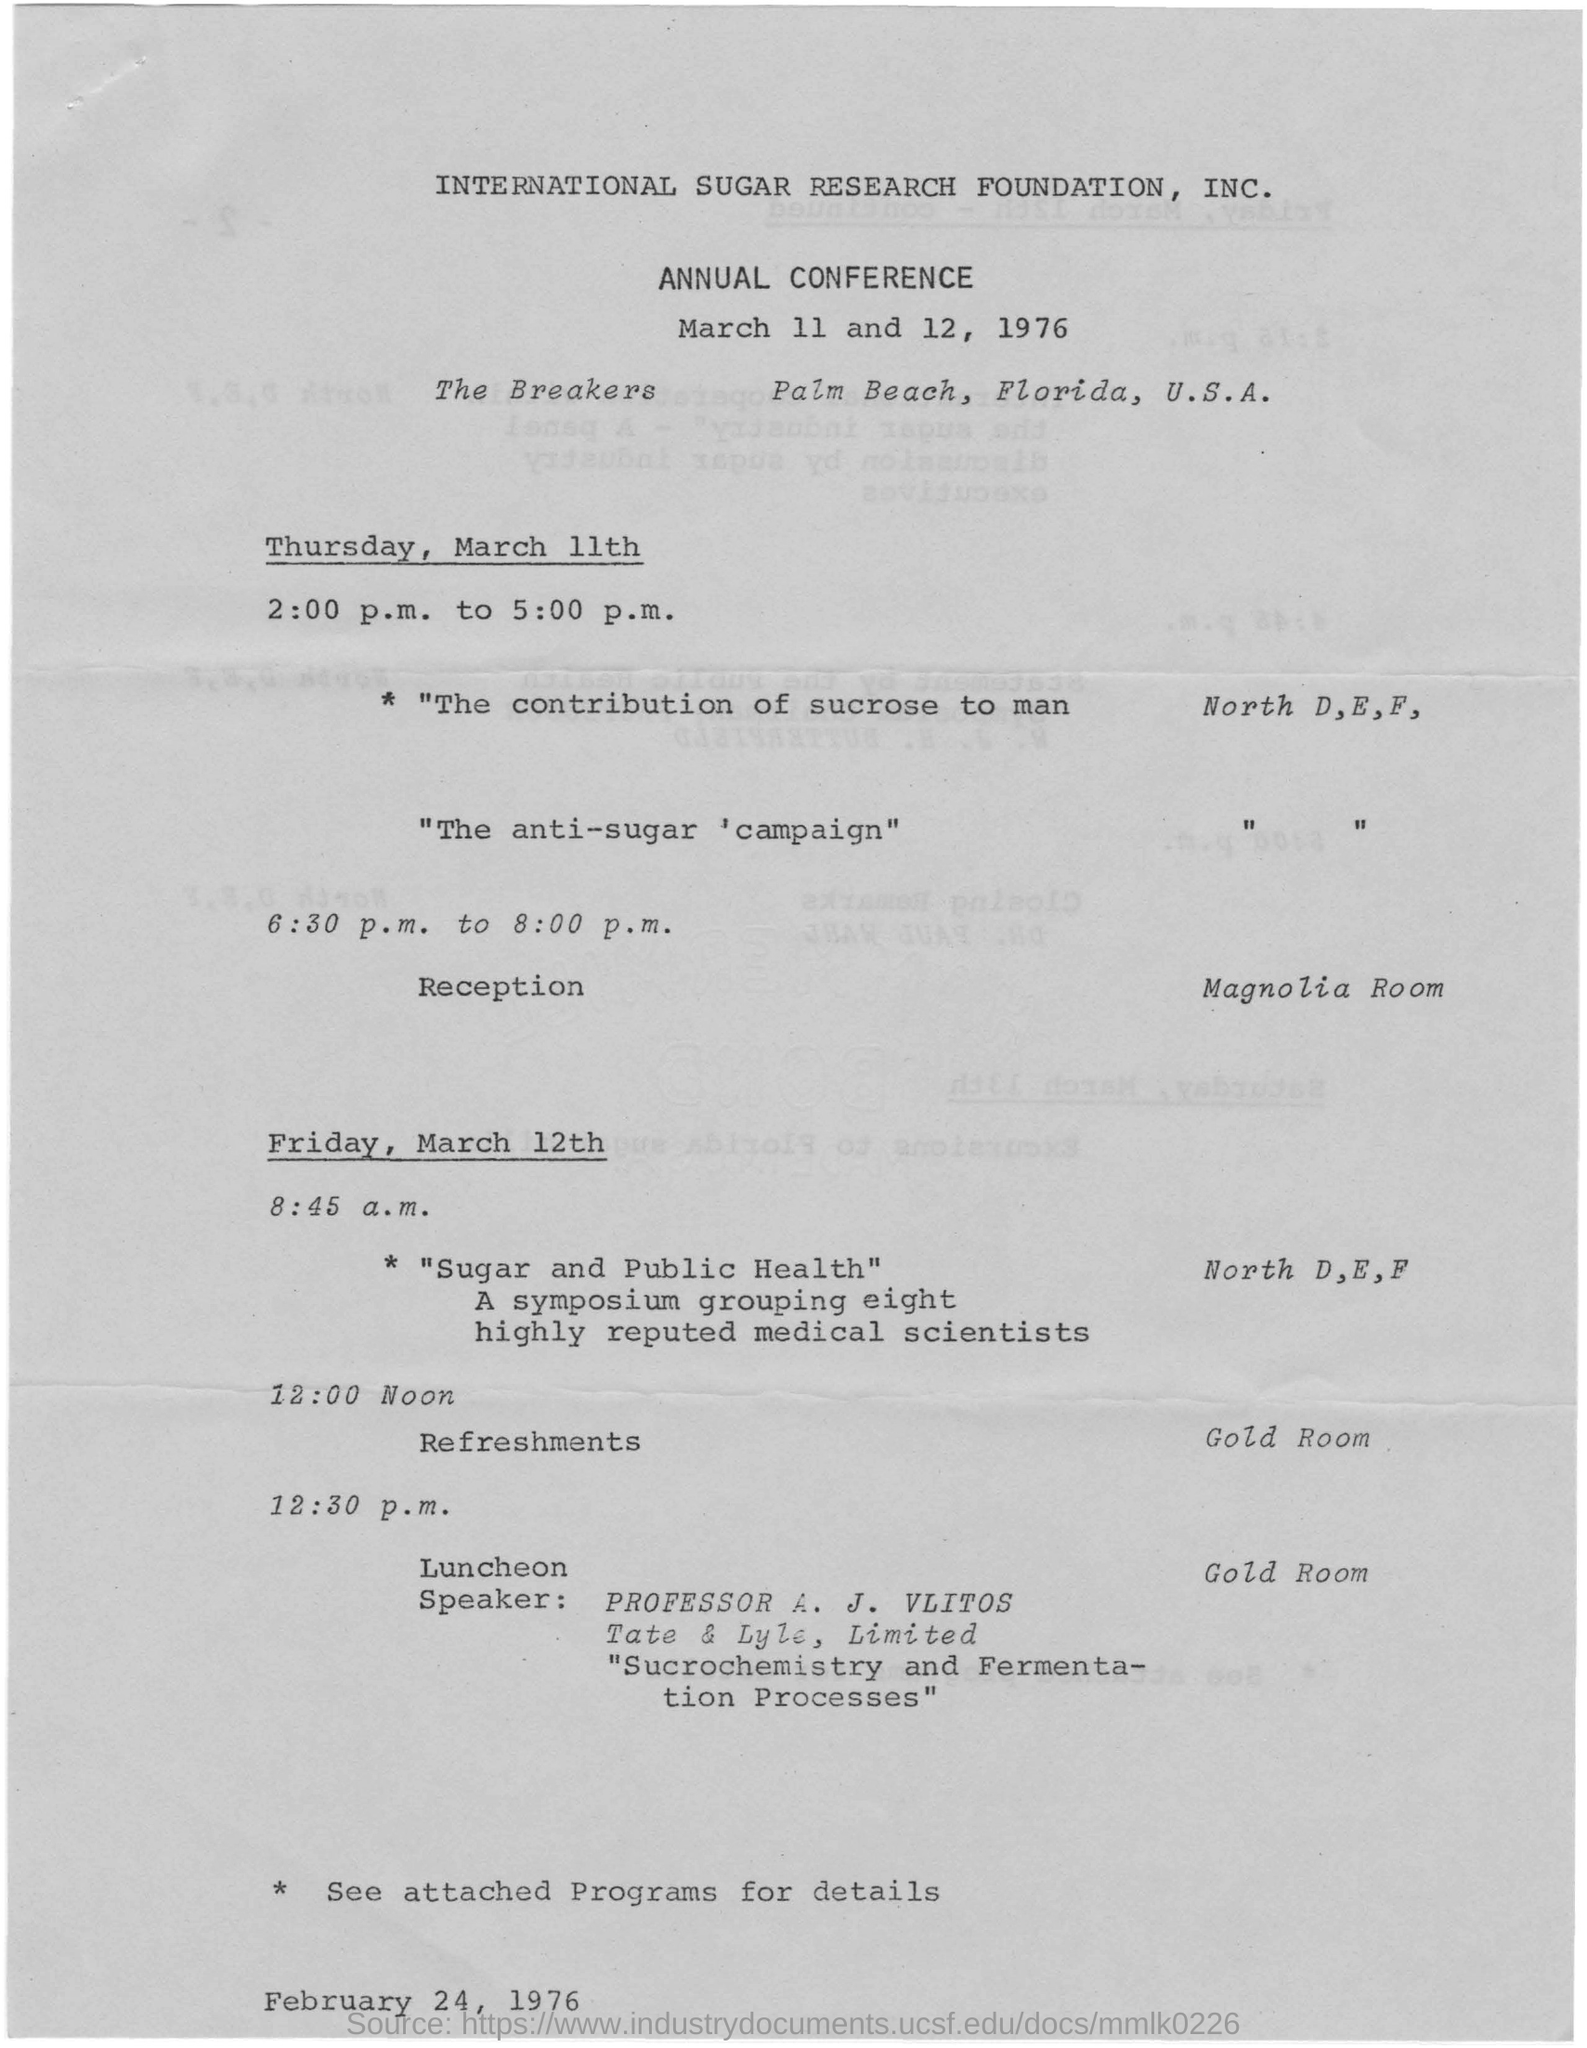Where is the reception held?
Provide a short and direct response. Mangolia room. Where is the annual conference held?
Ensure brevity in your answer.  The Breakers  Palm Beach, Florida, U.S.A. Who is the Speaker at the Luncheon?
Offer a very short reply. Professor A. J. VLITOS. What is the symposium about?
Provide a succinct answer. Sugar and Public Health. 